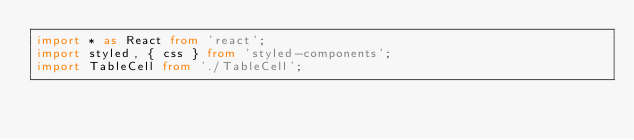Convert code to text. <code><loc_0><loc_0><loc_500><loc_500><_TypeScript_>import * as React from 'react';
import styled, { css } from 'styled-components';
import TableCell from './TableCell';</code> 